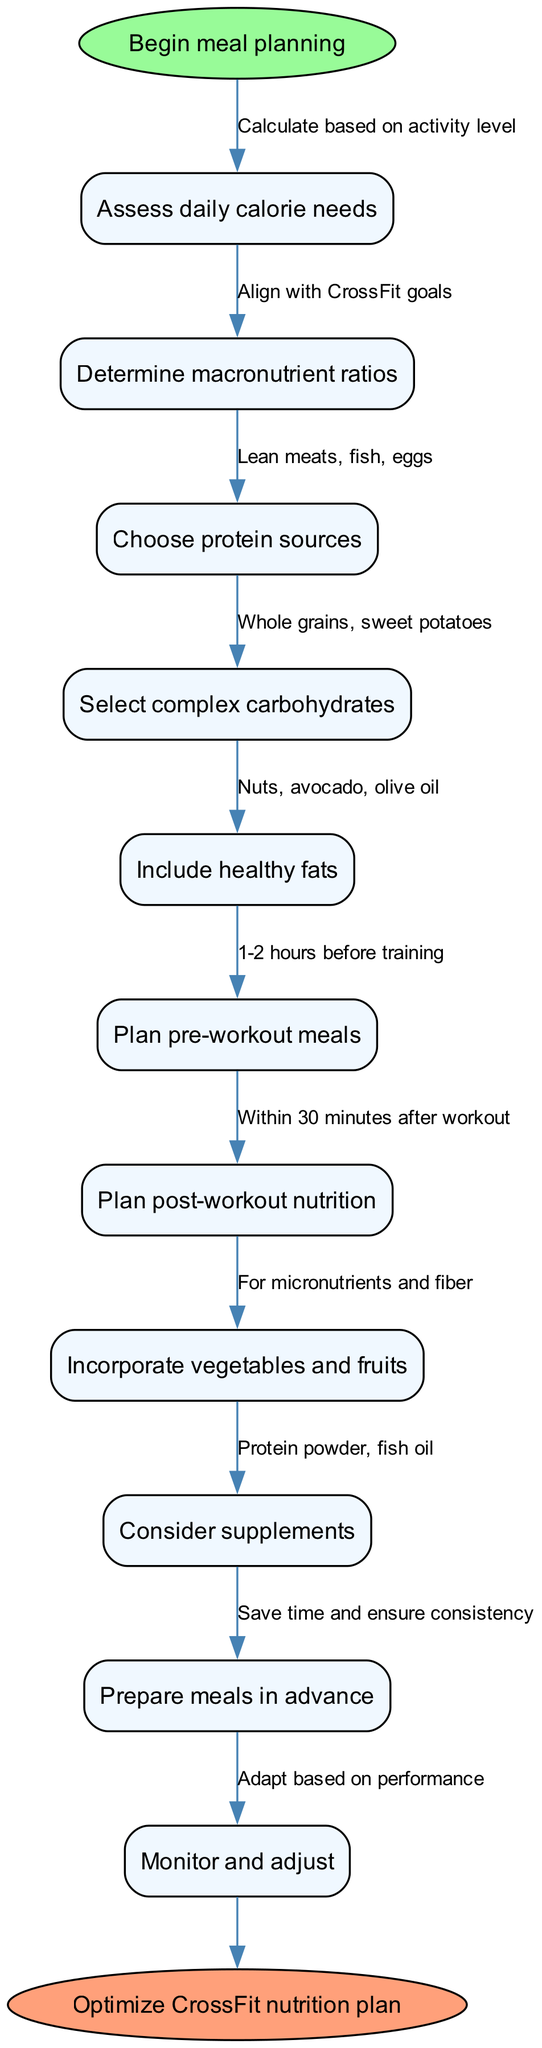What is the start of the meal planning process? The flowchart begins with the node labeled "Begin meal planning," which is the starting point of the process.
Answer: Begin meal planning How many main nodes are in the diagram? The diagram lists ten main nodes representing different steps in the meal planning process for nutrition optimization.
Answer: 10 What comes after assessing daily calorie needs? The next node following "Assess daily calorie needs" is "Determine macronutrient ratios," indicating the progression from calorie assessment to macronutrient guidance.
Answer: Determine macronutrient ratios What are the sources of protein suggested in the flowchart? The flowchart's node "Choose protein sources" specifies the sources as "Lean meats, fish, eggs," highlighting the recommended protein options.
Answer: Lean meats, fish, eggs How do you plan your post-workout nutrition? According to the flowchart, post-workout nutrition should be "Within 30 minutes after workout," stressing the timing for effective recovery.
Answer: Within 30 minutes after workout If you follow all steps correctly, what is the end goal of this flowchart? The flowchart concludes with the node labeled "Optimize CrossFit nutrition plan," signifying the ultimate aim after completing all previous steps.
Answer: Optimize CrossFit nutrition plan What type of foods should be included in the meal plan for carbohydrates? The diagram specifies "Whole grains, sweet potatoes" under the node for complex carbohydrates.
Answer: Whole grains, sweet potatoes What should you consider in terms of additional nutrition? The flowchart includes the node "Consider supplements," indicating that additional nutritional supports should be taken into account in the meal planning.
Answer: Consider supplements What action should you take after preparing meals? The flowchart suggests "Monitor and adjust" as the follow-up step after preparing meals, emphasizing the need for ongoing evaluation of nutritional strategies.
Answer: Monitor and adjust 